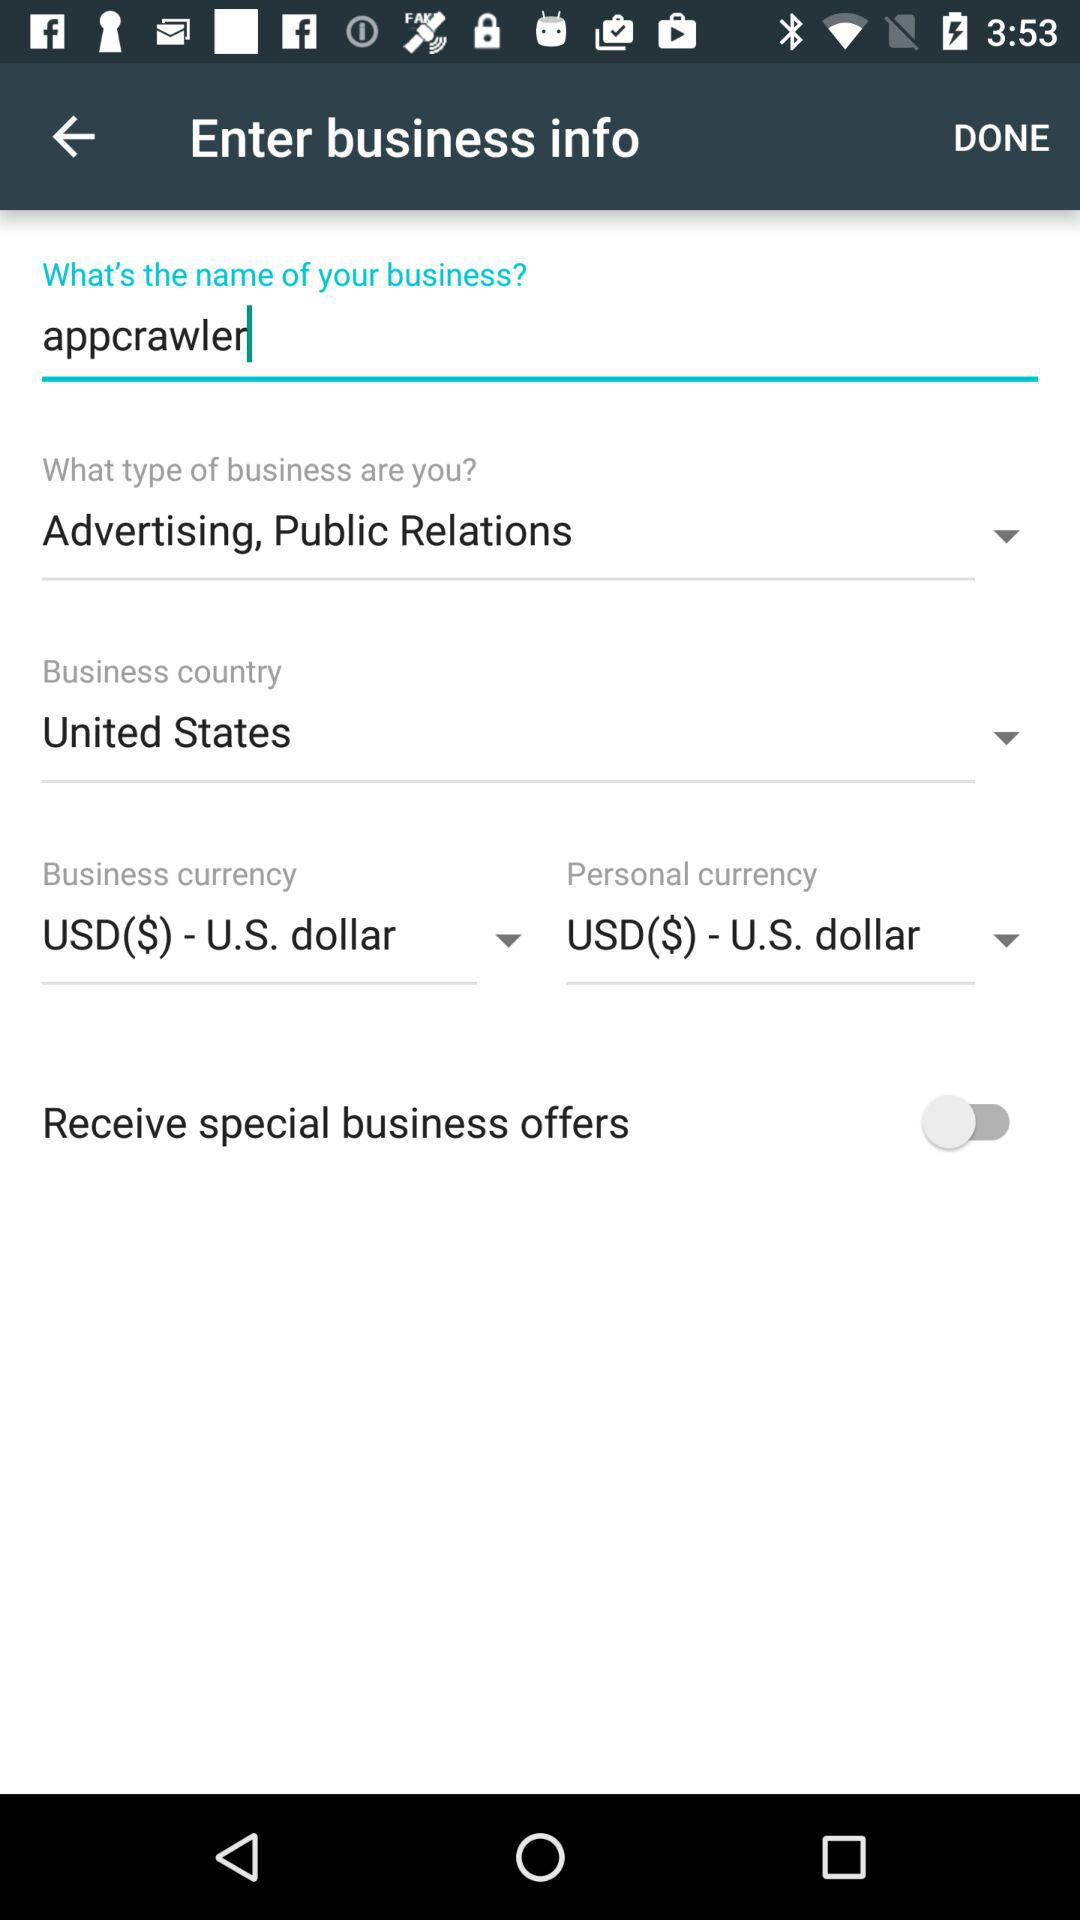What is the selected currency for personal? The selected currency is "USD($) - U.S. dollar". 